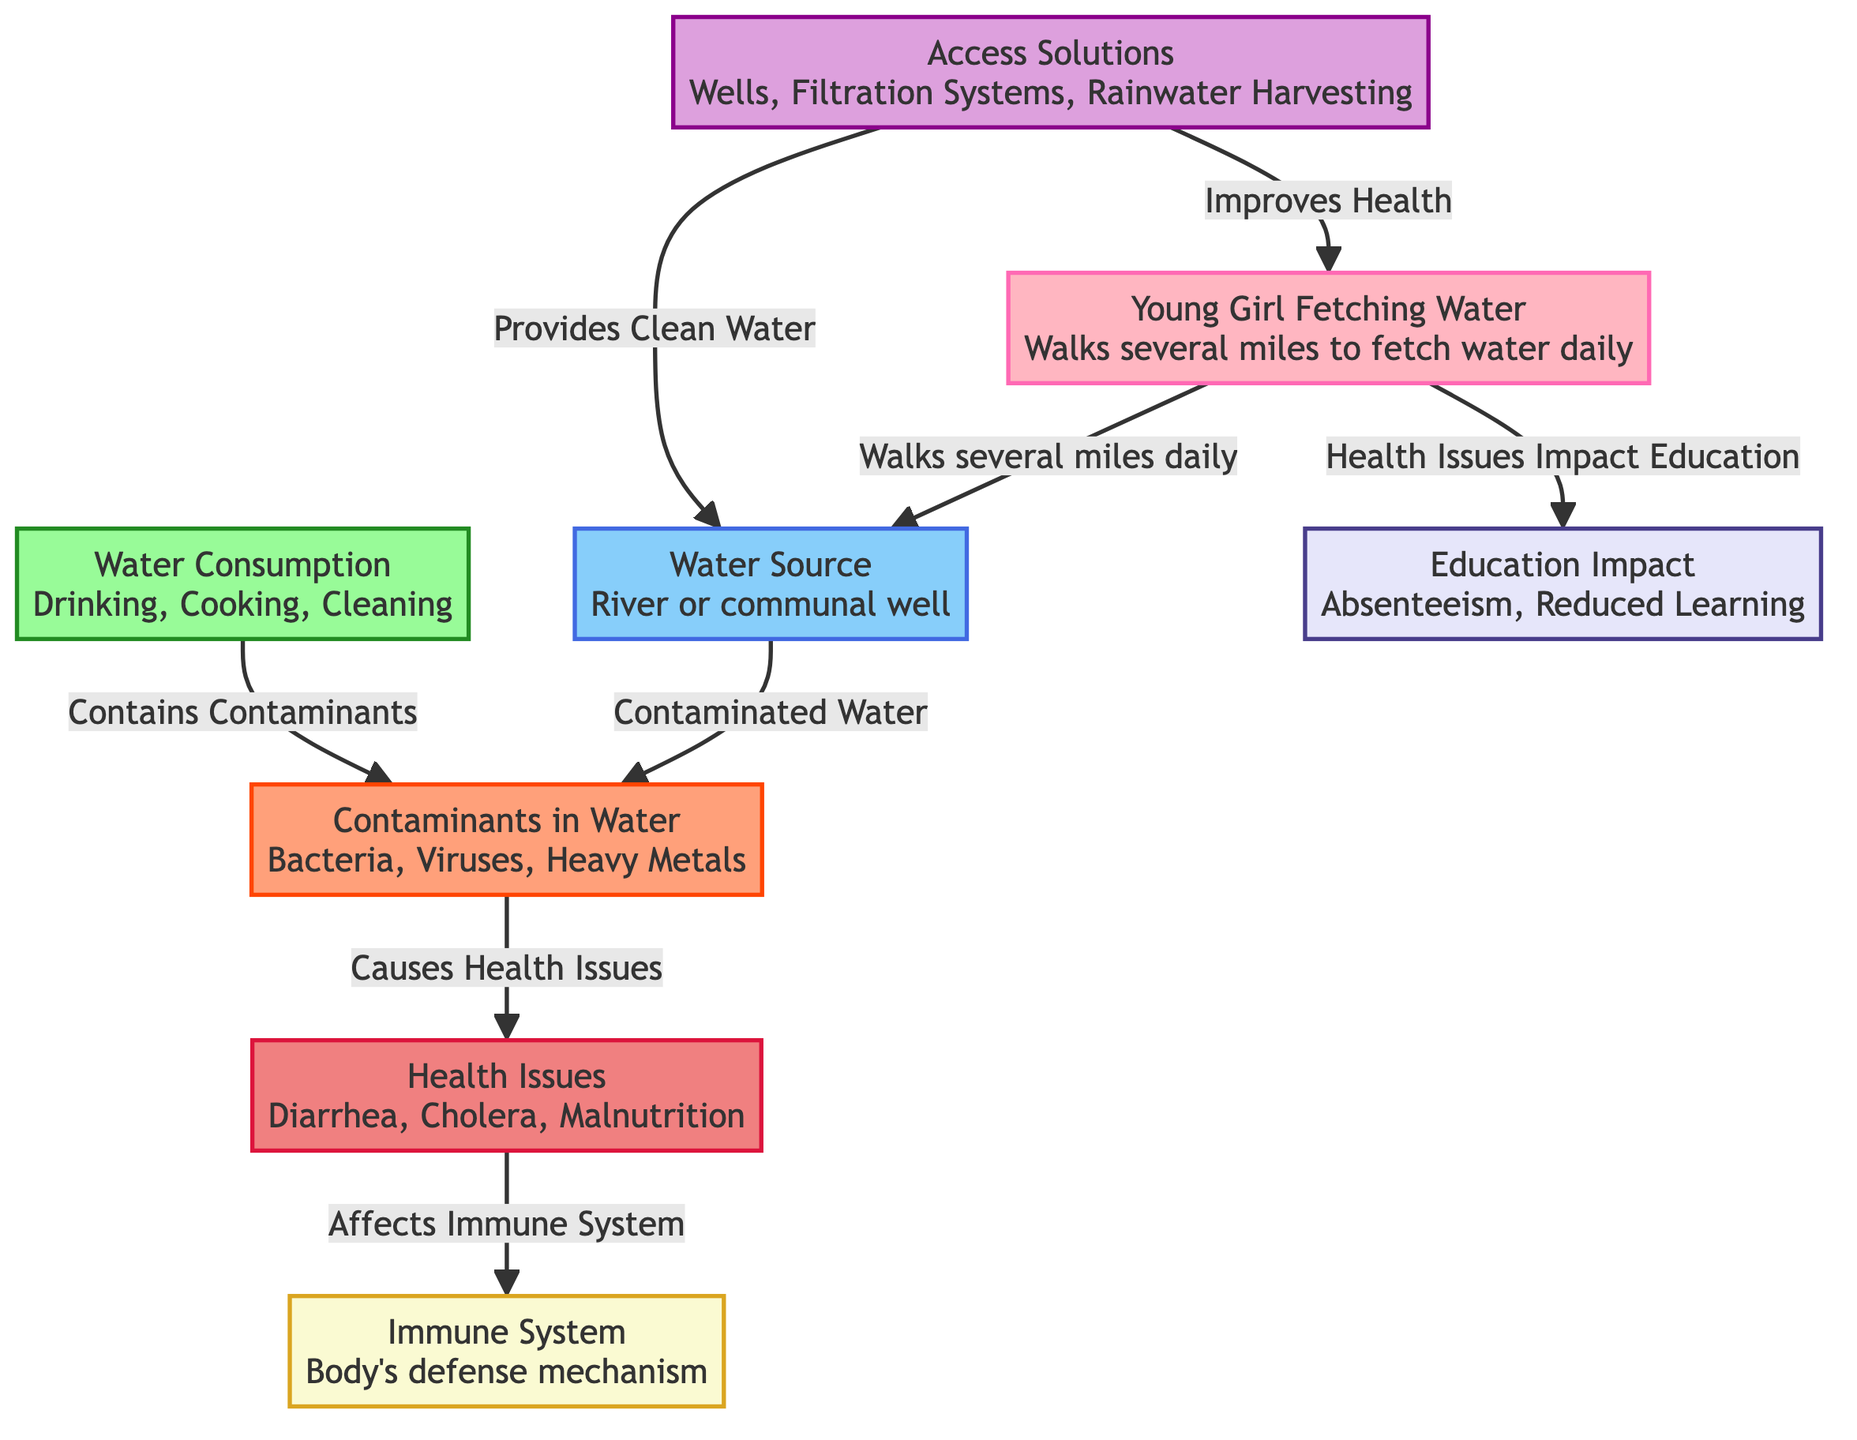What is the main source of water for the girl? The diagram indicates that the main source of water for the girl is either a river or a communal well, as shown in the "Water Source" node connected to the "Young Girl Fetching Water" node.
Answer: River or communal well What contaminates the water? The "Contaminants in Water" node lists specific contaminants such as bacteria, viruses, and heavy metals that are shown to affect the water quality, indicating what makes the water unsafe.
Answer: Bacteria, viruses, heavy metals What health issues arise from consuming contaminated water? The flow from the "Health Issues" node shows connections indicating that consuming contaminated water leads to issues like diarrhea, cholera, and malnutrition as highlighted in the diagram.
Answer: Diarrhea, cholera, malnutrition How does contaminated water affect the immune system? The diagram illustrates that health issues stemming from contaminated water have a direct impact on the immune system, which is shown as a connection from "Health Issues" to "Immune System". This means that health problems weaken the body's defense mechanism.
Answer: Affects immune system What solutions are provided for access to clean water? The "Access Solutions" node outlines several methods for improving access to clean water, such as wells, filtration systems, and rainwater harvesting, which are detailed in the diagram.
Answer: Wells, filtration systems, rainwater harvesting How does water consumption relate to contaminants? As depicted in the diagram, water consumption contains contaminants, which shows a direct relationship between how water is used (for drinking, cooking, and cleaning) and the risks associated with that contaminated water.
Answer: Contains contaminants What impact does health have on education? The diagram reveals that health issues caused by consuming contaminated water affect education, suggesting that health problems can lead to absenteeism and reduced learning opportunities for the girl.
Answer: Health issues impact education How can access solutions improve the girl's health? The "Access Solutions" node connects to the "Young Girl Fetching Water" node, indicating that implementing solutions such as providing clean water can significantly improve health. Thus, access solutions have a positive impact on the girl's well-being.
Answer: Improves health What is the connection between contaminated water and health issues? The diagram shows that contaminated water leads to health issues, illustrated by the connection from "Contaminants in Water" to "Health Issues", indicating that the presence of contaminants directly causes these health problems.
Answer: Causes health issues 